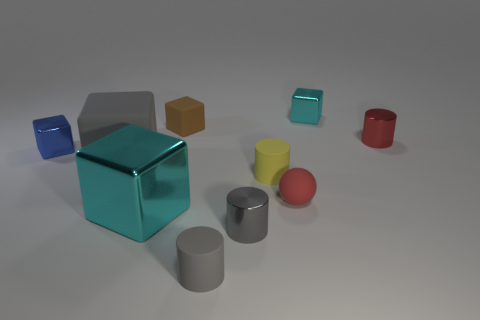Does the large gray thing have the same material as the small sphere? Based on the visual assessment, it appears that both the large gray object and the small sphere exhibit a similar level of shininess, which suggests they could be made of materials with comparable reflective properties, likely some type of glossy finish on a hard surface. However, without more context or tactile inspection, it is not possible to confirm with certainty if they are comprised of the exact same material. 